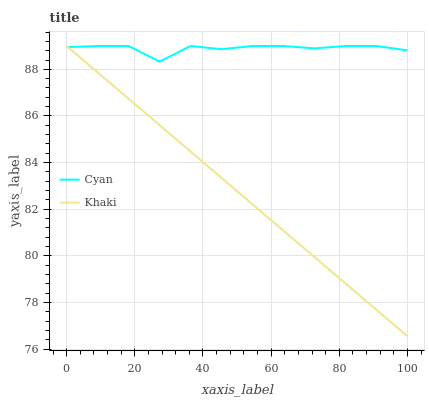Does Khaki have the minimum area under the curve?
Answer yes or no. Yes. Does Cyan have the maximum area under the curve?
Answer yes or no. Yes. Does Khaki have the maximum area under the curve?
Answer yes or no. No. Is Khaki the smoothest?
Answer yes or no. Yes. Is Cyan the roughest?
Answer yes or no. Yes. Is Khaki the roughest?
Answer yes or no. No. Does Khaki have the lowest value?
Answer yes or no. Yes. Does Khaki have the highest value?
Answer yes or no. Yes. Does Khaki intersect Cyan?
Answer yes or no. Yes. Is Khaki less than Cyan?
Answer yes or no. No. Is Khaki greater than Cyan?
Answer yes or no. No. 